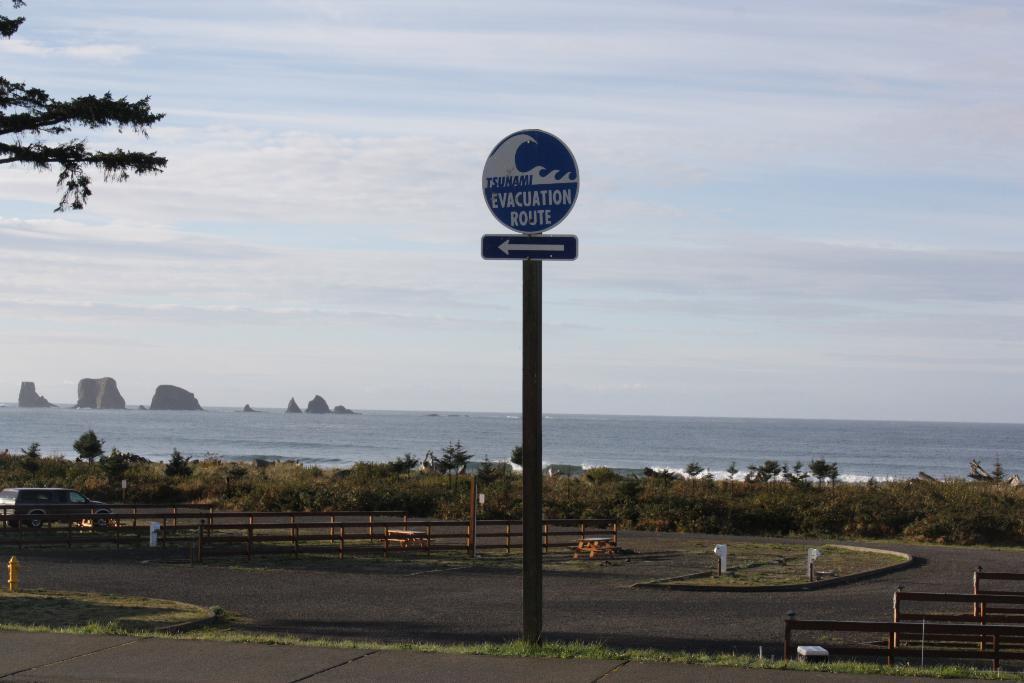Can you describe this image briefly? In this image, we can see name board and sign board with pole. At the bottom, there is a walkway, grass. On the right side, we can see few rods. Background there is a railings, vehicle, few plants, trees, sea. Top of the image, there is a sky. 